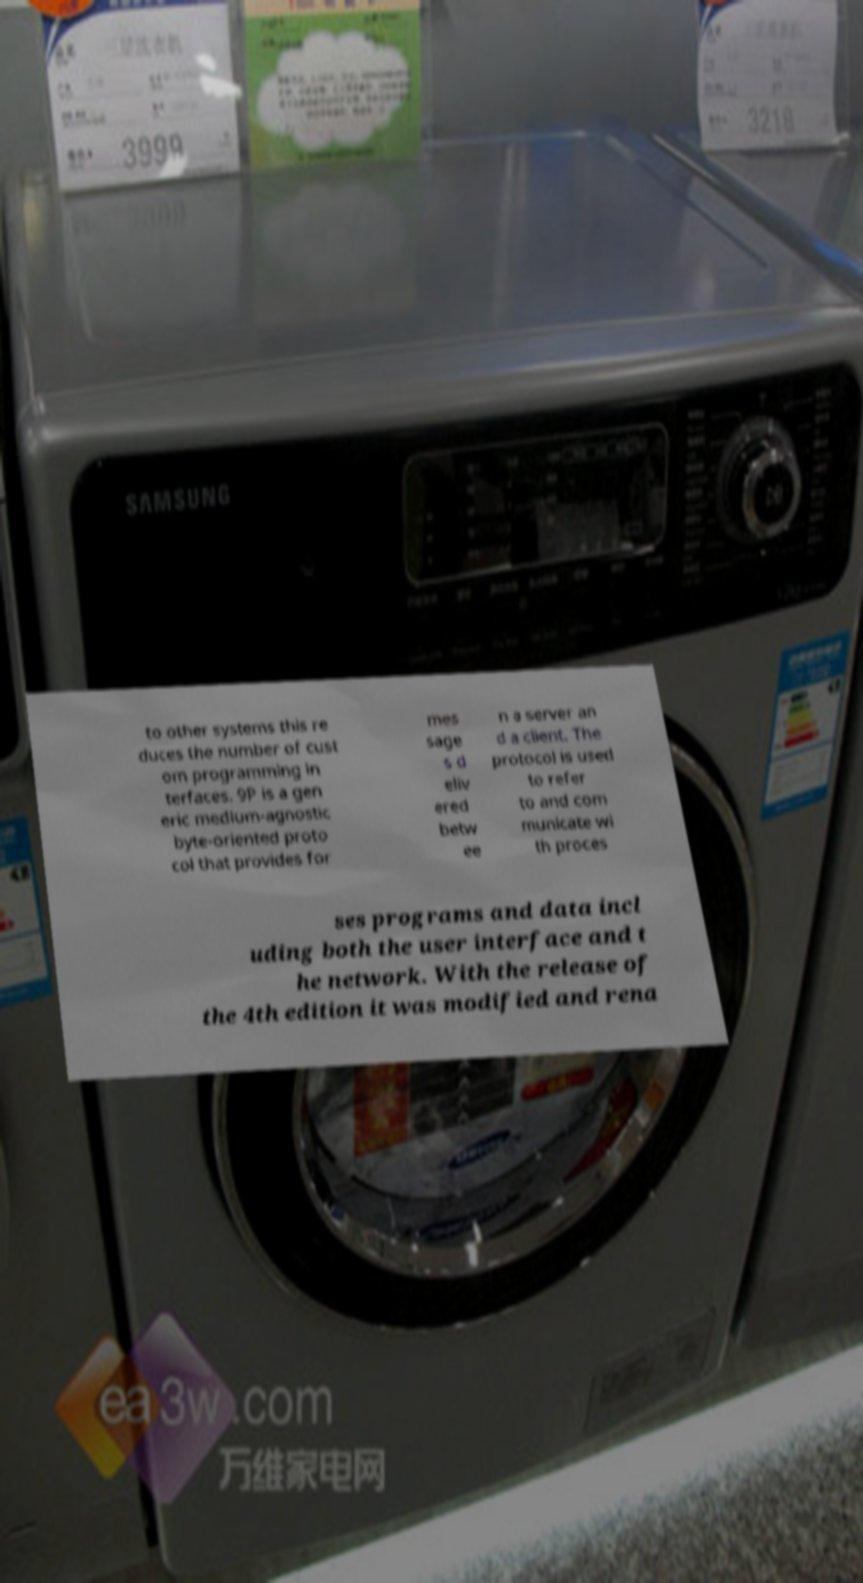Please identify and transcribe the text found in this image. to other systems this re duces the number of cust om programming in terfaces. 9P is a gen eric medium-agnostic byte-oriented proto col that provides for mes sage s d eliv ered betw ee n a server an d a client. The protocol is used to refer to and com municate wi th proces ses programs and data incl uding both the user interface and t he network. With the release of the 4th edition it was modified and rena 